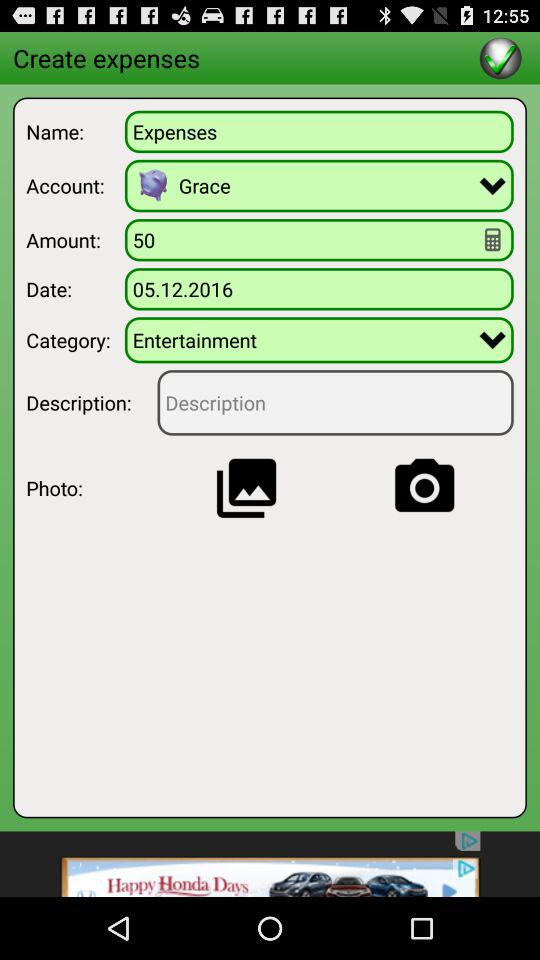What is the name of the ecpenses?
When the provided information is insufficient, respond with <no answer>. <no answer> 